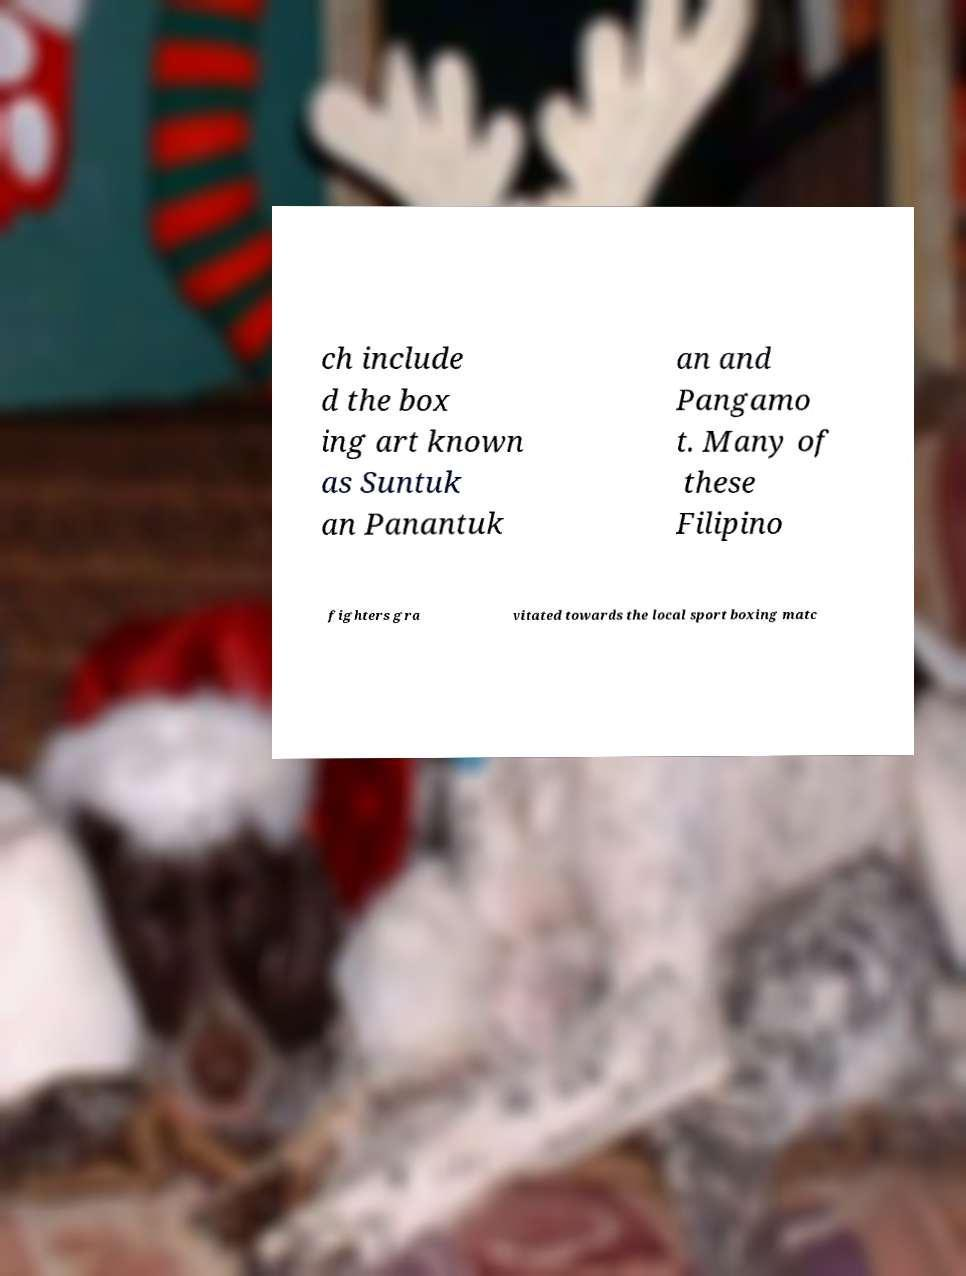Can you read and provide the text displayed in the image?This photo seems to have some interesting text. Can you extract and type it out for me? ch include d the box ing art known as Suntuk an Panantuk an and Pangamo t. Many of these Filipino fighters gra vitated towards the local sport boxing matc 